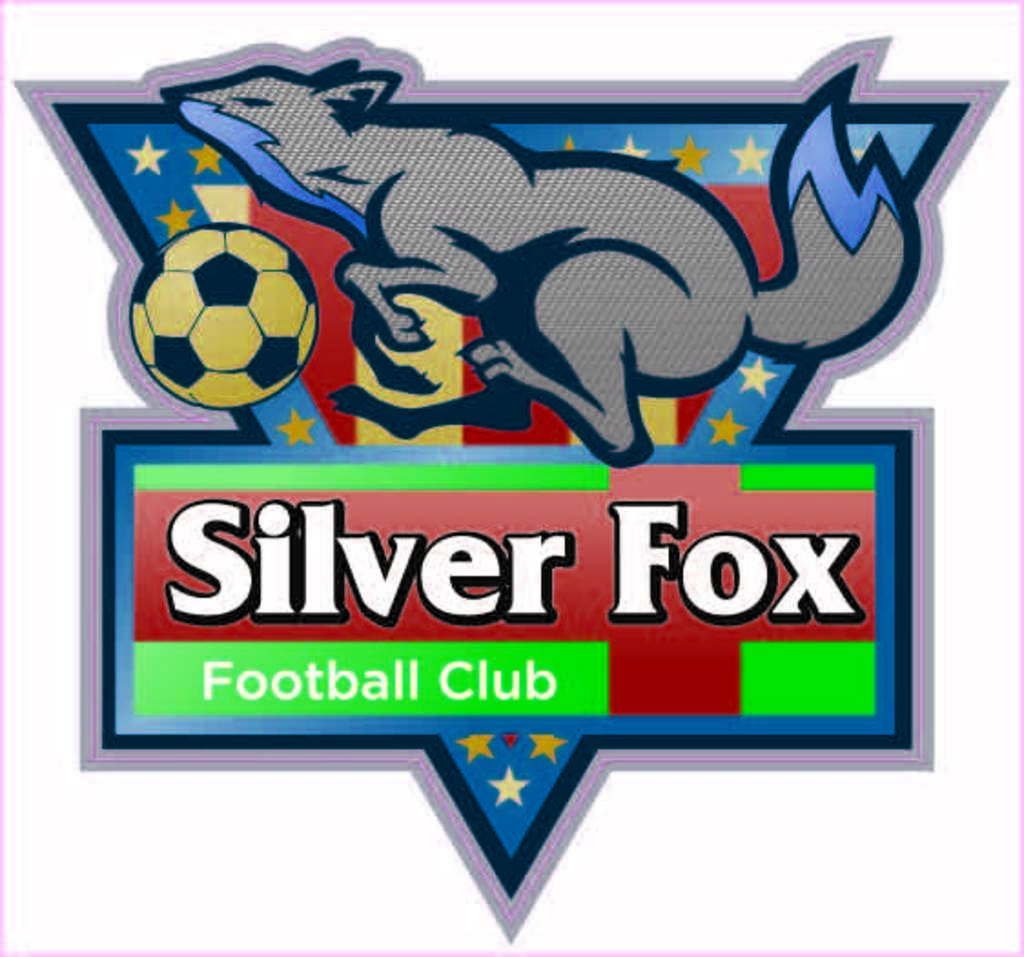Which sport does this club play?
Offer a terse response. Football. What is the name of the football club?
Your response must be concise. Silver fox. 